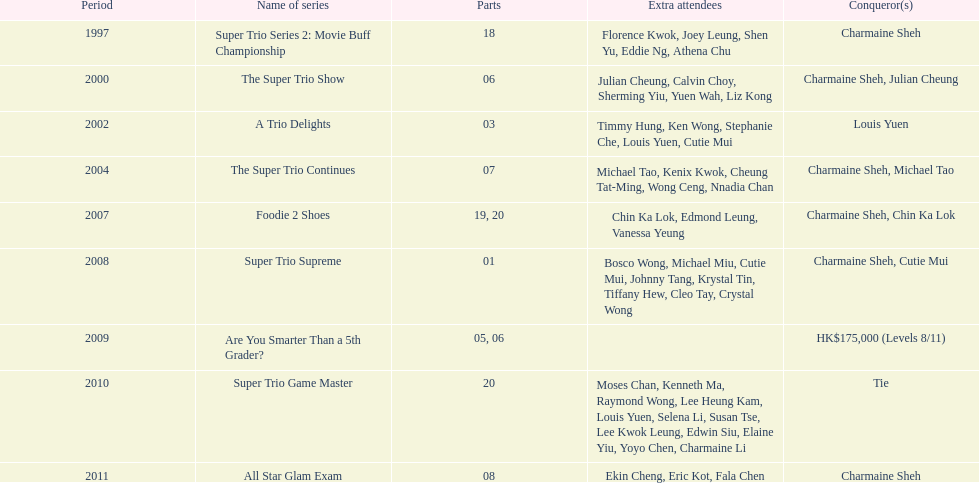How many consecutive trio shows did charmaine sheh do before being on another variety program? 34. 